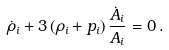<formula> <loc_0><loc_0><loc_500><loc_500>\dot { \rho } _ { i } + 3 \left ( \rho _ { i } + p _ { i } \right ) \frac { \dot { A } _ { i } } { A _ { i } } = 0 \, .</formula> 